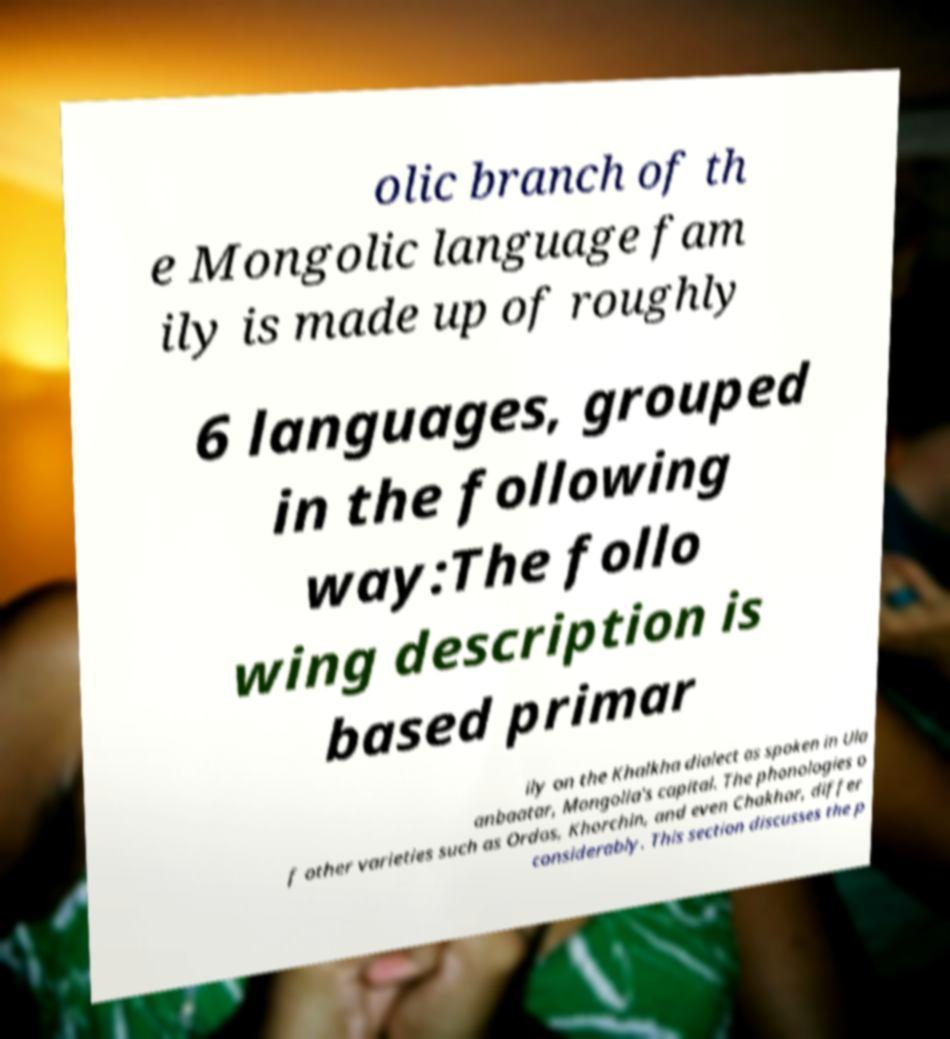For documentation purposes, I need the text within this image transcribed. Could you provide that? olic branch of th e Mongolic language fam ily is made up of roughly 6 languages, grouped in the following way:The follo wing description is based primar ily on the Khalkha dialect as spoken in Ula anbaatar, Mongolia's capital. The phonologies o f other varieties such as Ordos, Khorchin, and even Chakhar, differ considerably. This section discusses the p 